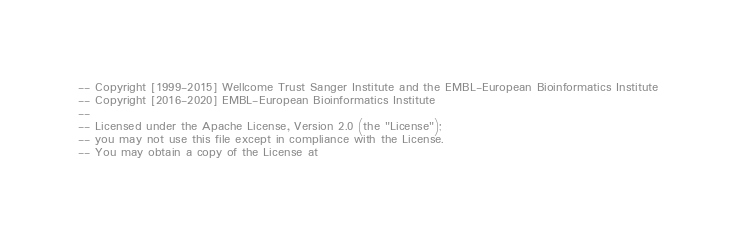Convert code to text. <code><loc_0><loc_0><loc_500><loc_500><_SQL_>-- Copyright [1999-2015] Wellcome Trust Sanger Institute and the EMBL-European Bioinformatics Institute
-- Copyright [2016-2020] EMBL-European Bioinformatics Institute
-- 
-- Licensed under the Apache License, Version 2.0 (the "License");
-- you may not use this file except in compliance with the License.
-- You may obtain a copy of the License at</code> 